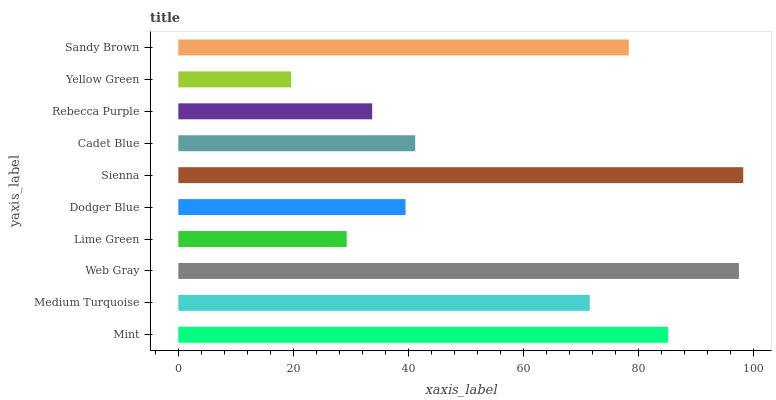Is Yellow Green the minimum?
Answer yes or no. Yes. Is Sienna the maximum?
Answer yes or no. Yes. Is Medium Turquoise the minimum?
Answer yes or no. No. Is Medium Turquoise the maximum?
Answer yes or no. No. Is Mint greater than Medium Turquoise?
Answer yes or no. Yes. Is Medium Turquoise less than Mint?
Answer yes or no. Yes. Is Medium Turquoise greater than Mint?
Answer yes or no. No. Is Mint less than Medium Turquoise?
Answer yes or no. No. Is Medium Turquoise the high median?
Answer yes or no. Yes. Is Cadet Blue the low median?
Answer yes or no. Yes. Is Cadet Blue the high median?
Answer yes or no. No. Is Mint the low median?
Answer yes or no. No. 